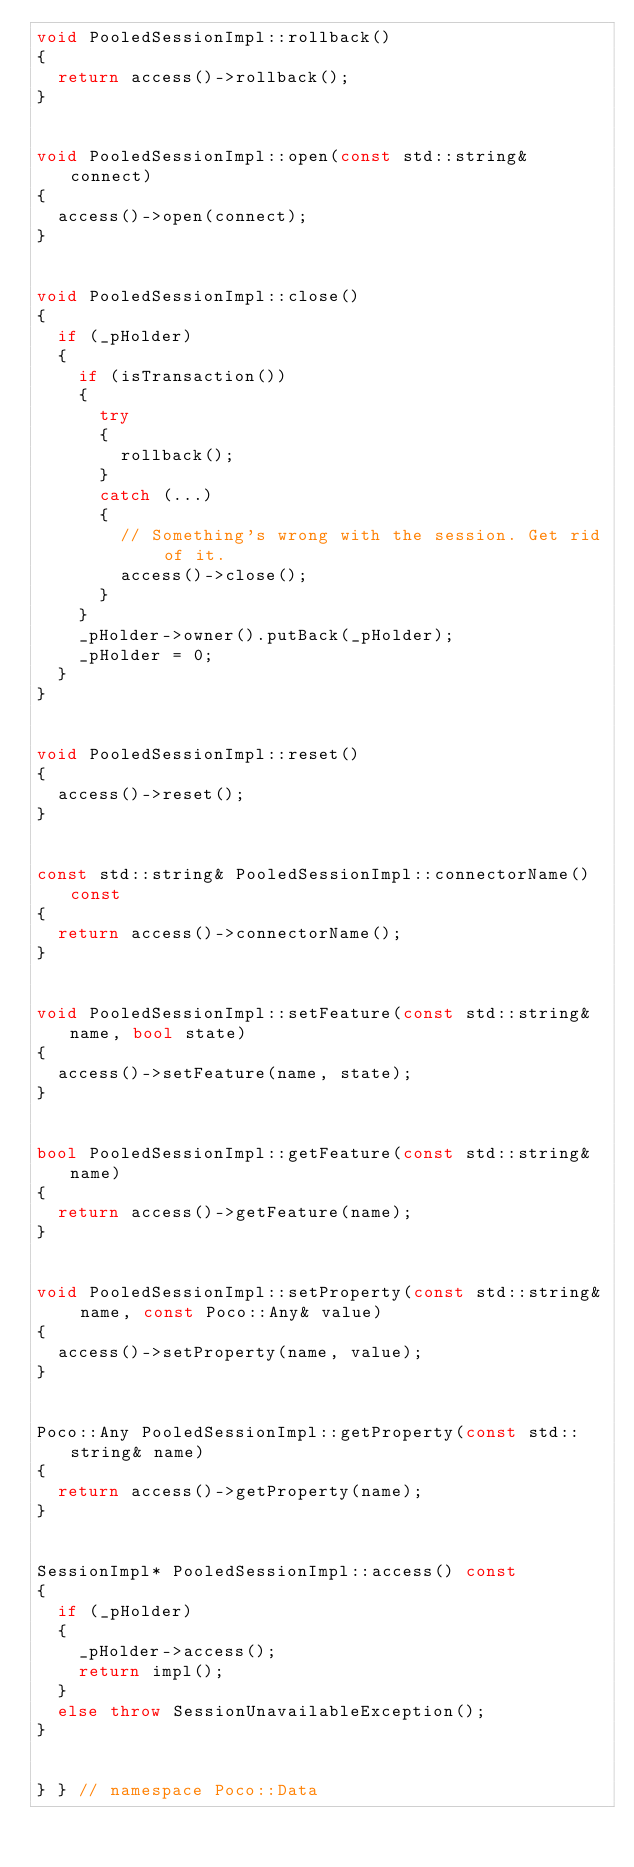<code> <loc_0><loc_0><loc_500><loc_500><_C++_>void PooledSessionImpl::rollback()
{
	return access()->rollback();
}


void PooledSessionImpl::open(const std::string& connect)
{
	access()->open(connect);
}


void PooledSessionImpl::close()
{
	if (_pHolder)
	{
		if (isTransaction())
		{
			try
			{
				rollback();
			}
			catch (...)
			{
				// Something's wrong with the session. Get rid of it.
				access()->close();
			}
		}
		_pHolder->owner().putBack(_pHolder);
		_pHolder = 0;
	}
}


void PooledSessionImpl::reset()
{
	access()->reset();
}


const std::string& PooledSessionImpl::connectorName() const
{
	return access()->connectorName();
}


void PooledSessionImpl::setFeature(const std::string& name, bool state)
{
	access()->setFeature(name, state);
}


bool PooledSessionImpl::getFeature(const std::string& name)
{
	return access()->getFeature(name);
}


void PooledSessionImpl::setProperty(const std::string& name, const Poco::Any& value)
{
	access()->setProperty(name, value);
}


Poco::Any PooledSessionImpl::getProperty(const std::string& name)
{
	return access()->getProperty(name);
}


SessionImpl* PooledSessionImpl::access() const
{
	if (_pHolder)
	{
		_pHolder->access();
		return impl();
	}
	else throw SessionUnavailableException();
}


} } // namespace Poco::Data
</code> 